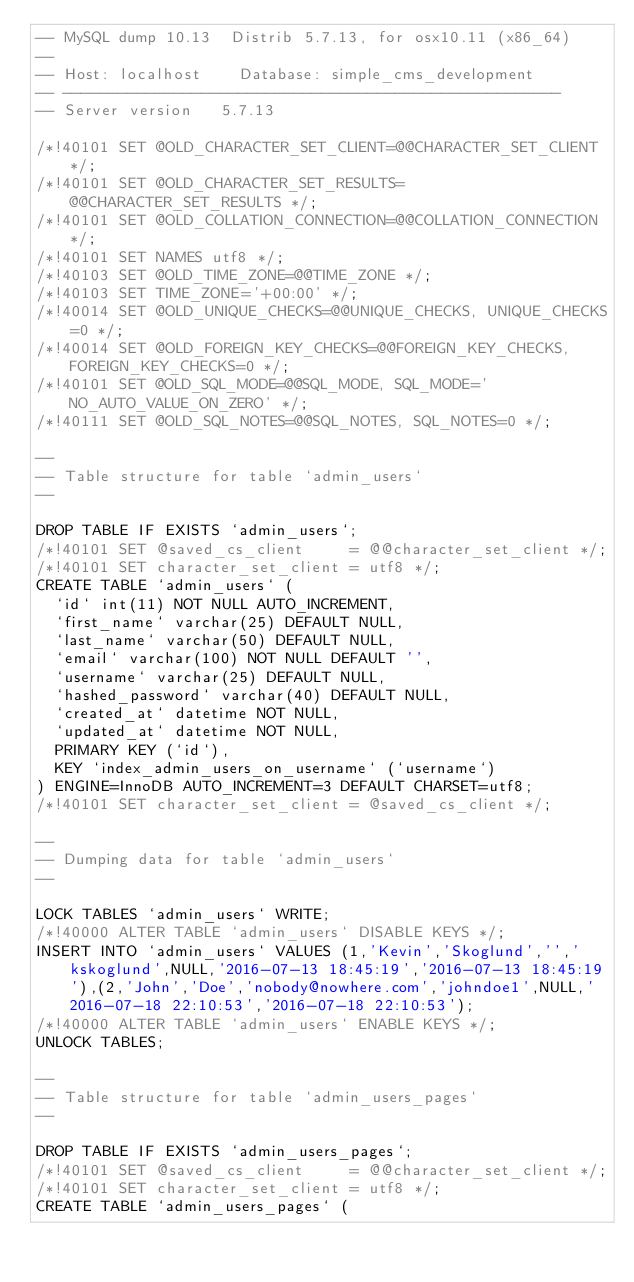Convert code to text. <code><loc_0><loc_0><loc_500><loc_500><_SQL_>-- MySQL dump 10.13  Distrib 5.7.13, for osx10.11 (x86_64)
--
-- Host: localhost    Database: simple_cms_development
-- ------------------------------------------------------
-- Server version	5.7.13

/*!40101 SET @OLD_CHARACTER_SET_CLIENT=@@CHARACTER_SET_CLIENT */;
/*!40101 SET @OLD_CHARACTER_SET_RESULTS=@@CHARACTER_SET_RESULTS */;
/*!40101 SET @OLD_COLLATION_CONNECTION=@@COLLATION_CONNECTION */;
/*!40101 SET NAMES utf8 */;
/*!40103 SET @OLD_TIME_ZONE=@@TIME_ZONE */;
/*!40103 SET TIME_ZONE='+00:00' */;
/*!40014 SET @OLD_UNIQUE_CHECKS=@@UNIQUE_CHECKS, UNIQUE_CHECKS=0 */;
/*!40014 SET @OLD_FOREIGN_KEY_CHECKS=@@FOREIGN_KEY_CHECKS, FOREIGN_KEY_CHECKS=0 */;
/*!40101 SET @OLD_SQL_MODE=@@SQL_MODE, SQL_MODE='NO_AUTO_VALUE_ON_ZERO' */;
/*!40111 SET @OLD_SQL_NOTES=@@SQL_NOTES, SQL_NOTES=0 */;

--
-- Table structure for table `admin_users`
--

DROP TABLE IF EXISTS `admin_users`;
/*!40101 SET @saved_cs_client     = @@character_set_client */;
/*!40101 SET character_set_client = utf8 */;
CREATE TABLE `admin_users` (
  `id` int(11) NOT NULL AUTO_INCREMENT,
  `first_name` varchar(25) DEFAULT NULL,
  `last_name` varchar(50) DEFAULT NULL,
  `email` varchar(100) NOT NULL DEFAULT '',
  `username` varchar(25) DEFAULT NULL,
  `hashed_password` varchar(40) DEFAULT NULL,
  `created_at` datetime NOT NULL,
  `updated_at` datetime NOT NULL,
  PRIMARY KEY (`id`),
  KEY `index_admin_users_on_username` (`username`)
) ENGINE=InnoDB AUTO_INCREMENT=3 DEFAULT CHARSET=utf8;
/*!40101 SET character_set_client = @saved_cs_client */;

--
-- Dumping data for table `admin_users`
--

LOCK TABLES `admin_users` WRITE;
/*!40000 ALTER TABLE `admin_users` DISABLE KEYS */;
INSERT INTO `admin_users` VALUES (1,'Kevin','Skoglund','','kskoglund',NULL,'2016-07-13 18:45:19','2016-07-13 18:45:19'),(2,'John','Doe','nobody@nowhere.com','johndoe1',NULL,'2016-07-18 22:10:53','2016-07-18 22:10:53');
/*!40000 ALTER TABLE `admin_users` ENABLE KEYS */;
UNLOCK TABLES;

--
-- Table structure for table `admin_users_pages`
--

DROP TABLE IF EXISTS `admin_users_pages`;
/*!40101 SET @saved_cs_client     = @@character_set_client */;
/*!40101 SET character_set_client = utf8 */;
CREATE TABLE `admin_users_pages` (</code> 